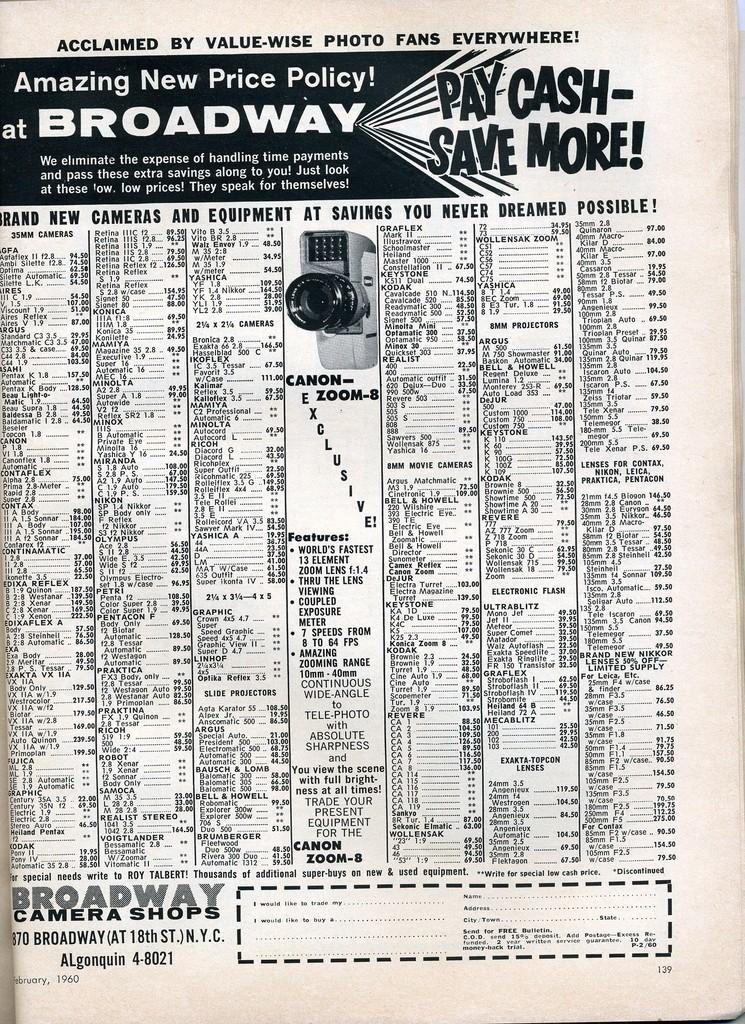What is the main subject of the image? The main subject of the image is an advertisement. Can you describe the color scheme of the advertisement? The advertisement is in black and white. How much wealth is displayed in the advertisement? There is no indication of wealth in the advertisement, as it is in black and white and does not show any objects or people associated with wealth. What type of suit is being advertised in the image? There is no suit present in the image, as it only features an advertisement in black and white. 